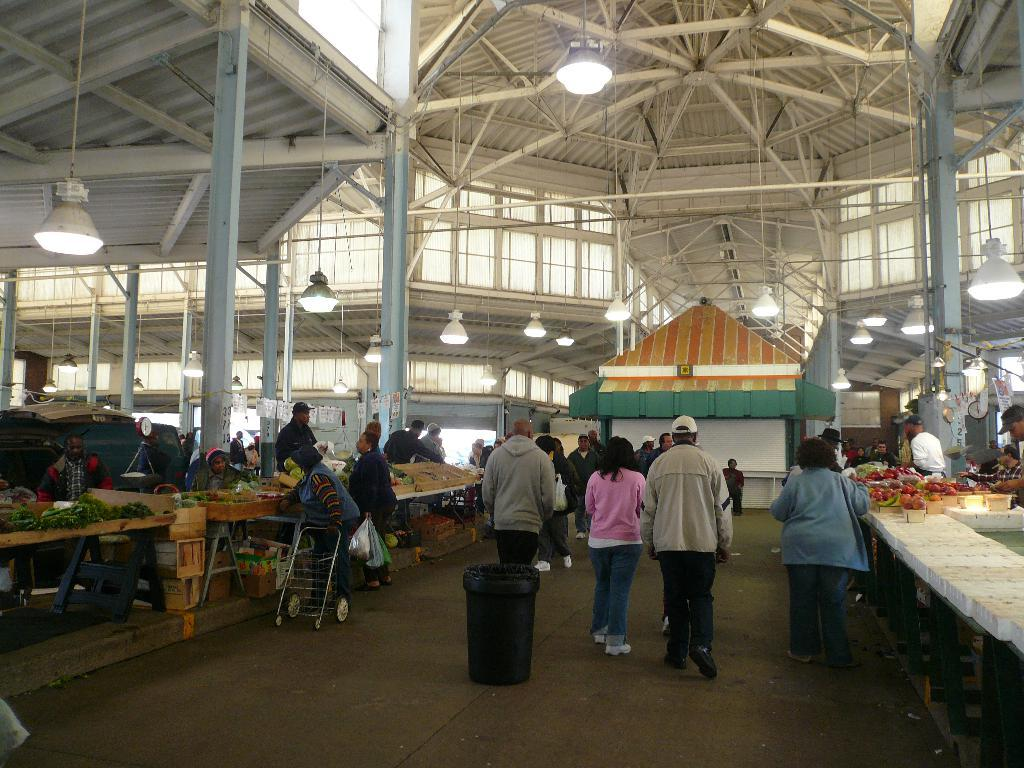What can be seen on the ground in the image? There are people on the ground in the image. What type of object is present for carrying a child? There is a stroller in the image. What type of food items are visible in the image? There are vegetables in the image. What type of furniture is present in the image? There are tables in the image. What type of illumination is present in the image? There are lights in the image. What type of grain is being harvested by the people in the image? There is no grain present in the image, and the people are not engaged in any harvesting activity. What invention is being demonstrated by the people in the image? There is no invention being demonstrated by the people in the image; they are simply standing on the ground. 